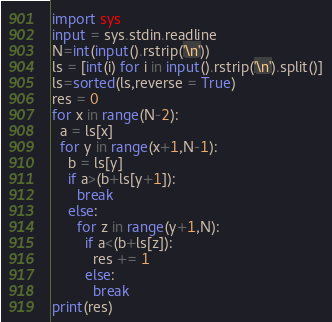<code> <loc_0><loc_0><loc_500><loc_500><_Python_>import sys
input = sys.stdin.readline
N=int(input().rstrip('\n'))
ls = [int(i) for i in input().rstrip('\n').split()]
ls=sorted(ls,reverse = True)
res = 0
for x in range(N-2):
  a = ls[x]
  for y in range(x+1,N-1):
    b = ls[y]
    if a>(b+ls[y+1]):
      break
    else:
      for z in range(y+1,N):
        if a<(b+ls[z]):
          res += 1
        else:
          break
print(res)</code> 